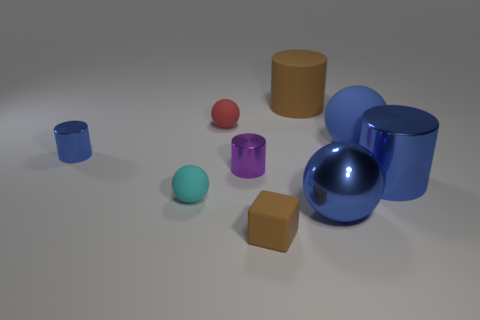Subtract 1 cylinders. How many cylinders are left? 3 Add 1 brown rubber blocks. How many objects exist? 10 Subtract all blocks. How many objects are left? 8 Add 1 tiny gray metallic cubes. How many tiny gray metallic cubes exist? 1 Subtract 0 red cylinders. How many objects are left? 9 Subtract all big objects. Subtract all small red things. How many objects are left? 4 Add 1 blue rubber spheres. How many blue rubber spheres are left? 2 